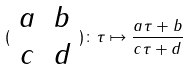Convert formula to latex. <formula><loc_0><loc_0><loc_500><loc_500>( \begin{array} { c c } a & b \\ c & d \end{array} ) \colon \tau \mapsto \frac { a \tau + b } { c \tau + d }</formula> 